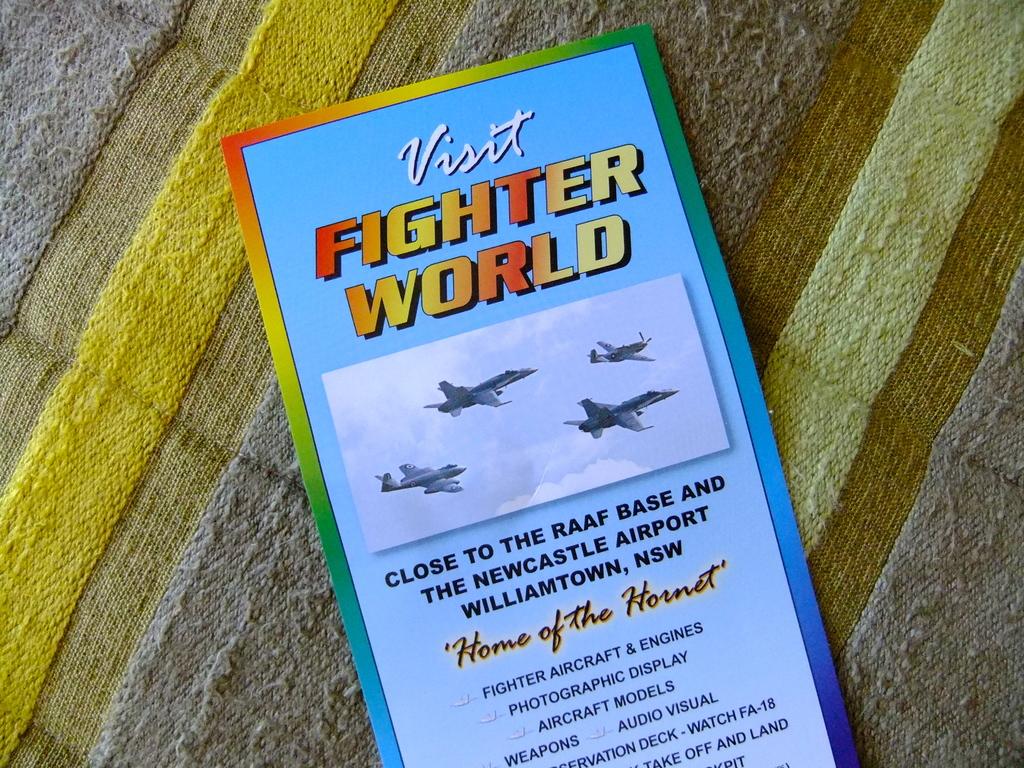Home of the what?
Offer a very short reply. Hornet. Where is fighter world located?
Offer a very short reply. Williamtown, nsw. 